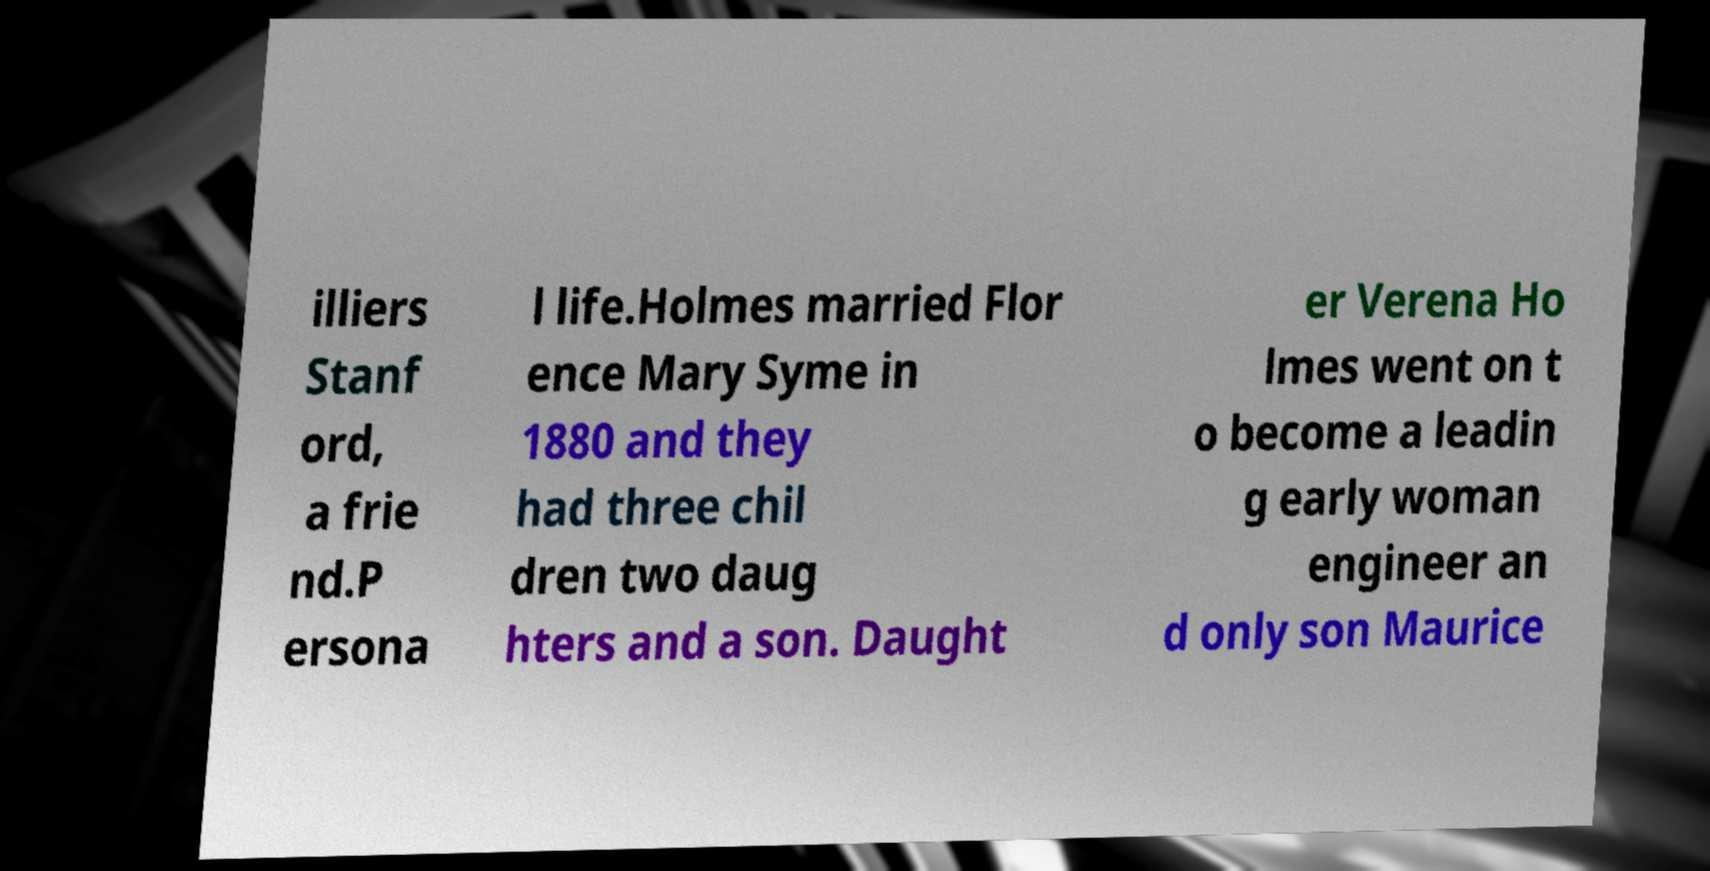Can you accurately transcribe the text from the provided image for me? illiers Stanf ord, a frie nd.P ersona l life.Holmes married Flor ence Mary Syme in 1880 and they had three chil dren two daug hters and a son. Daught er Verena Ho lmes went on t o become a leadin g early woman engineer an d only son Maurice 